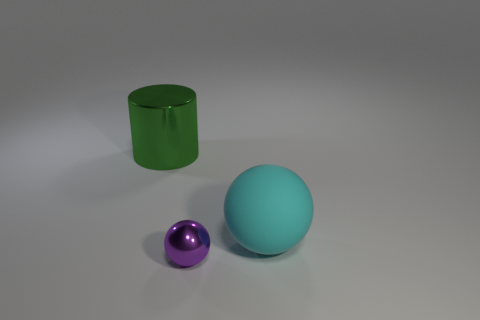Are there any tiny objects?
Give a very brief answer. Yes. There is a shiny thing in front of the metallic object behind the sphere on the left side of the cyan ball; what is its size?
Your answer should be compact. Small. What number of other tiny balls are the same material as the tiny purple sphere?
Make the answer very short. 0. What number of metal balls are the same size as the cyan matte thing?
Provide a succinct answer. 0. What material is the ball that is in front of the big thing to the right of the shiny thing on the left side of the purple object?
Ensure brevity in your answer.  Metal. How many objects are either cyan things or purple shiny spheres?
Make the answer very short. 2. Is there anything else that is the same material as the purple sphere?
Give a very brief answer. Yes. The purple object is what shape?
Offer a terse response. Sphere. There is a large thing that is to the right of the large object that is behind the cyan ball; what is its shape?
Provide a short and direct response. Sphere. Is the object that is to the left of the purple metallic sphere made of the same material as the large cyan object?
Your answer should be very brief. No. 